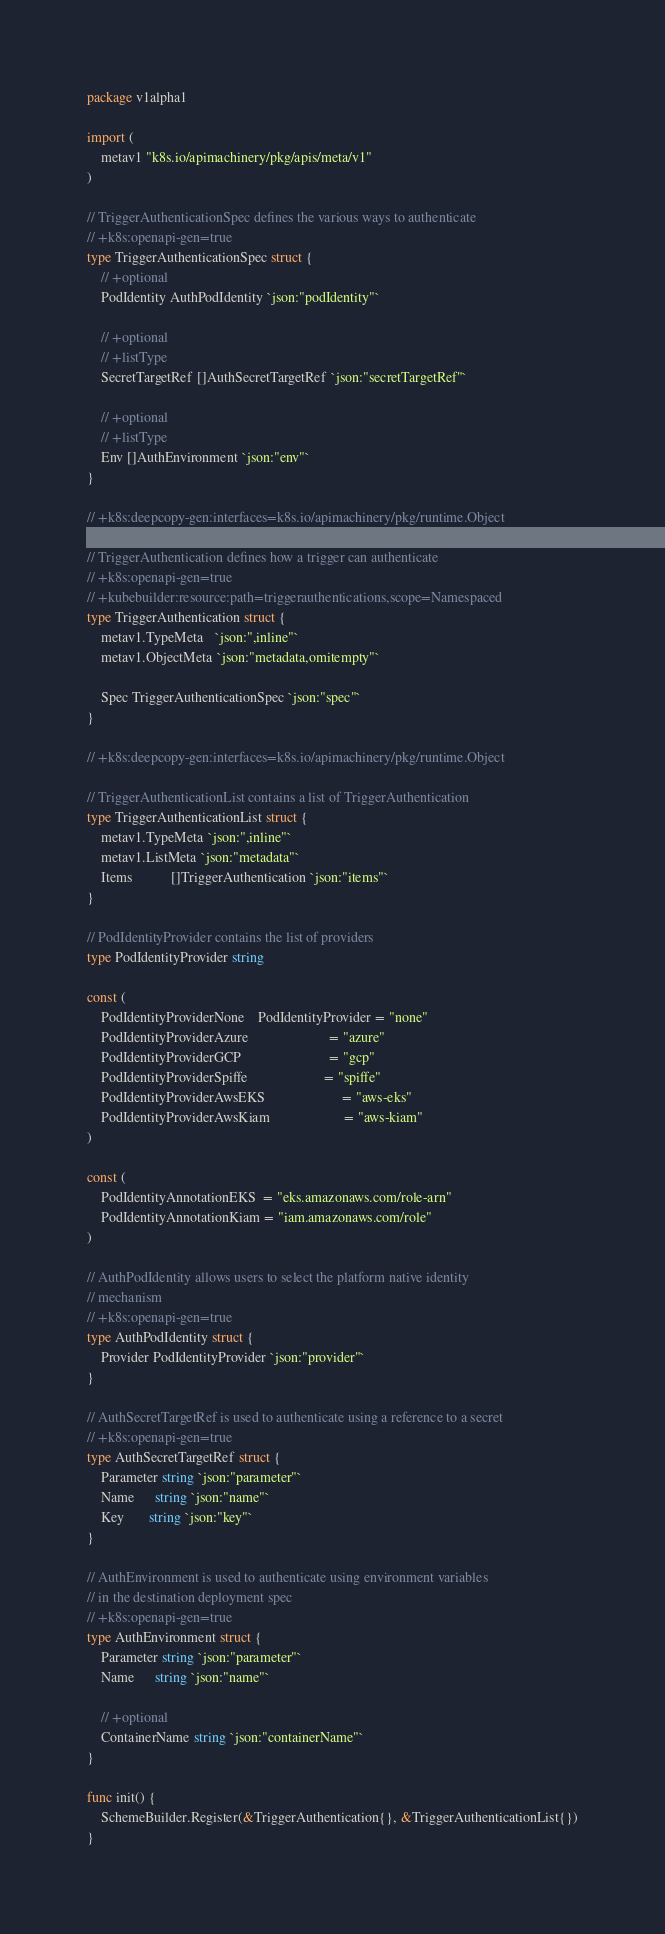Convert code to text. <code><loc_0><loc_0><loc_500><loc_500><_Go_>package v1alpha1

import (
	metav1 "k8s.io/apimachinery/pkg/apis/meta/v1"
)

// TriggerAuthenticationSpec defines the various ways to authenticate
// +k8s:openapi-gen=true
type TriggerAuthenticationSpec struct {
	// +optional
	PodIdentity AuthPodIdentity `json:"podIdentity"`

	// +optional
	// +listType
	SecretTargetRef []AuthSecretTargetRef `json:"secretTargetRef"`

	// +optional
	// +listType
	Env []AuthEnvironment `json:"env"`
}

// +k8s:deepcopy-gen:interfaces=k8s.io/apimachinery/pkg/runtime.Object

// TriggerAuthentication defines how a trigger can authenticate
// +k8s:openapi-gen=true
// +kubebuilder:resource:path=triggerauthentications,scope=Namespaced
type TriggerAuthentication struct {
	metav1.TypeMeta   `json:",inline"`
	metav1.ObjectMeta `json:"metadata,omitempty"`

	Spec TriggerAuthenticationSpec `json:"spec"`
}

// +k8s:deepcopy-gen:interfaces=k8s.io/apimachinery/pkg/runtime.Object

// TriggerAuthenticationList contains a list of TriggerAuthentication
type TriggerAuthenticationList struct {
	metav1.TypeMeta `json:",inline"`
	metav1.ListMeta `json:"metadata"`
	Items           []TriggerAuthentication `json:"items"`
}

// PodIdentityProvider contains the list of providers
type PodIdentityProvider string

const (
	PodIdentityProviderNone    PodIdentityProvider = "none"
	PodIdentityProviderAzure                       = "azure"
	PodIdentityProviderGCP                         = "gcp"
	PodIdentityProviderSpiffe                      = "spiffe"
	PodIdentityProviderAwsEKS                      = "aws-eks"
	PodIdentityProviderAwsKiam                     = "aws-kiam"
)

const (
	PodIdentityAnnotationEKS  = "eks.amazonaws.com/role-arn"
	PodIdentityAnnotationKiam = "iam.amazonaws.com/role"
)

// AuthPodIdentity allows users to select the platform native identity
// mechanism
// +k8s:openapi-gen=true
type AuthPodIdentity struct {
	Provider PodIdentityProvider `json:"provider"`
}

// AuthSecretTargetRef is used to authenticate using a reference to a secret
// +k8s:openapi-gen=true
type AuthSecretTargetRef struct {
	Parameter string `json:"parameter"`
	Name      string `json:"name"`
	Key       string `json:"key"`
}

// AuthEnvironment is used to authenticate using environment variables
// in the destination deployment spec
// +k8s:openapi-gen=true
type AuthEnvironment struct {
	Parameter string `json:"parameter"`
	Name      string `json:"name"`

	// +optional
	ContainerName string `json:"containerName"`
}

func init() {
	SchemeBuilder.Register(&TriggerAuthentication{}, &TriggerAuthenticationList{})
}
</code> 